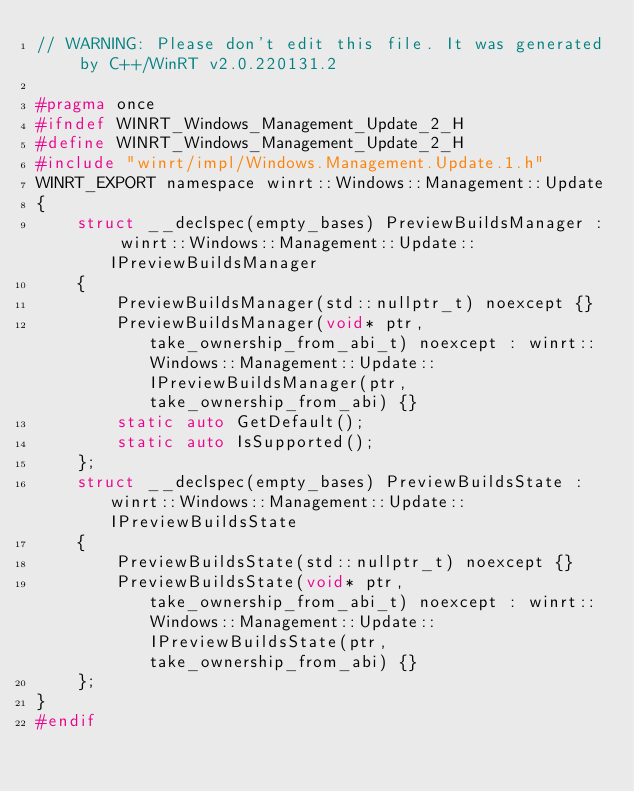Convert code to text. <code><loc_0><loc_0><loc_500><loc_500><_C_>// WARNING: Please don't edit this file. It was generated by C++/WinRT v2.0.220131.2

#pragma once
#ifndef WINRT_Windows_Management_Update_2_H
#define WINRT_Windows_Management_Update_2_H
#include "winrt/impl/Windows.Management.Update.1.h"
WINRT_EXPORT namespace winrt::Windows::Management::Update
{
    struct __declspec(empty_bases) PreviewBuildsManager : winrt::Windows::Management::Update::IPreviewBuildsManager
    {
        PreviewBuildsManager(std::nullptr_t) noexcept {}
        PreviewBuildsManager(void* ptr, take_ownership_from_abi_t) noexcept : winrt::Windows::Management::Update::IPreviewBuildsManager(ptr, take_ownership_from_abi) {}
        static auto GetDefault();
        static auto IsSupported();
    };
    struct __declspec(empty_bases) PreviewBuildsState : winrt::Windows::Management::Update::IPreviewBuildsState
    {
        PreviewBuildsState(std::nullptr_t) noexcept {}
        PreviewBuildsState(void* ptr, take_ownership_from_abi_t) noexcept : winrt::Windows::Management::Update::IPreviewBuildsState(ptr, take_ownership_from_abi) {}
    };
}
#endif
</code> 